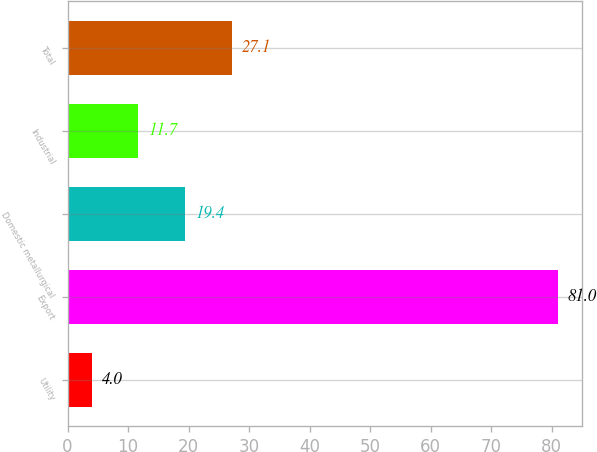Convert chart. <chart><loc_0><loc_0><loc_500><loc_500><bar_chart><fcel>Utility<fcel>Export<fcel>Domestic metallurgical<fcel>Industrial<fcel>Total<nl><fcel>4<fcel>81<fcel>19.4<fcel>11.7<fcel>27.1<nl></chart> 